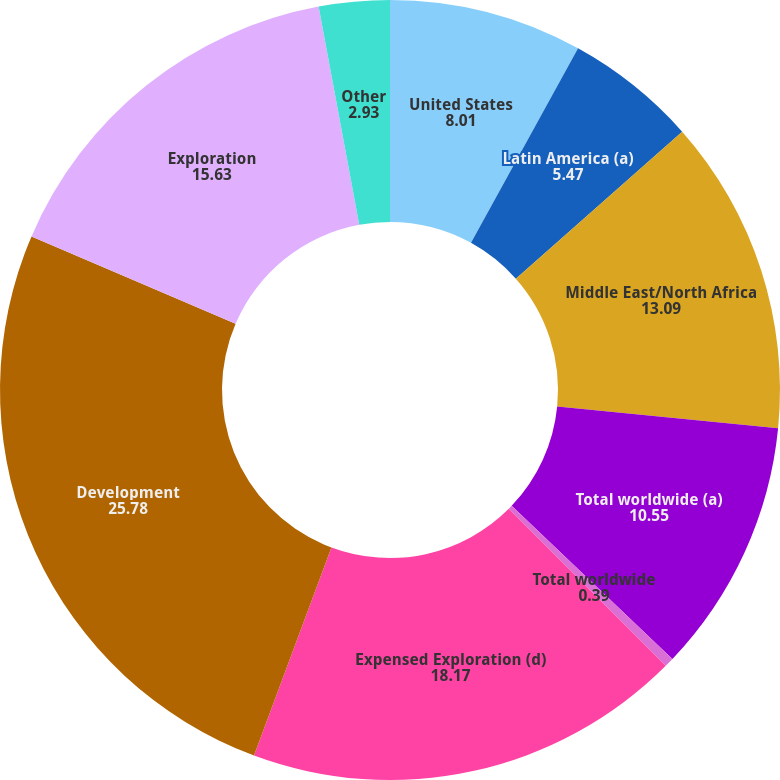Convert chart. <chart><loc_0><loc_0><loc_500><loc_500><pie_chart><fcel>United States<fcel>Latin America (a)<fcel>Middle East/North Africa<fcel>Total worldwide (a)<fcel>Total worldwide<fcel>Expensed Exploration (d)<fcel>Development<fcel>Exploration<fcel>Other<nl><fcel>8.01%<fcel>5.47%<fcel>13.09%<fcel>10.55%<fcel>0.39%<fcel>18.17%<fcel>25.78%<fcel>15.63%<fcel>2.93%<nl></chart> 